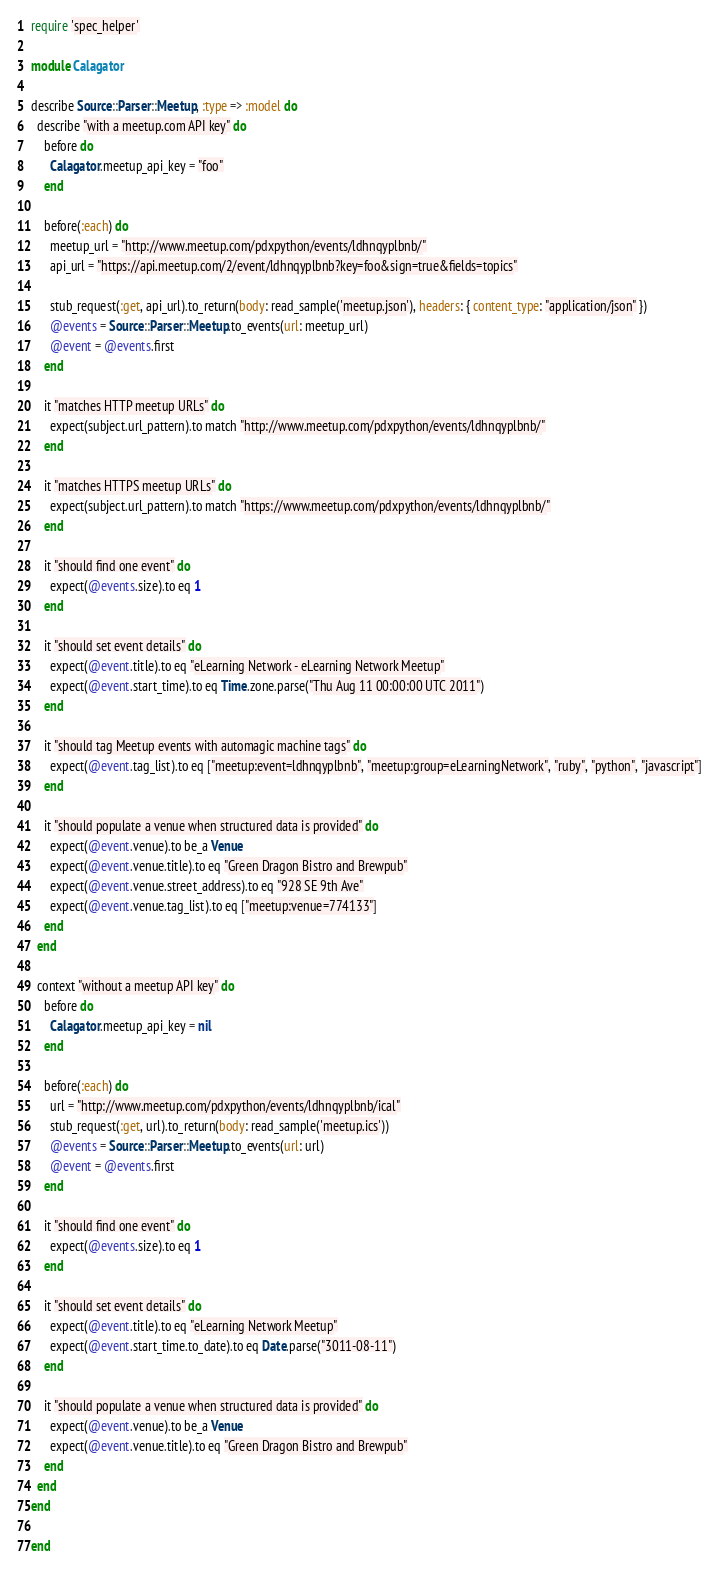<code> <loc_0><loc_0><loc_500><loc_500><_Ruby_>require 'spec_helper'

module Calagator

describe Source::Parser::Meetup, :type => :model do
  describe "with a meetup.com API key" do
    before do
      Calagator.meetup_api_key = "foo"
    end

    before(:each) do
      meetup_url = "http://www.meetup.com/pdxpython/events/ldhnqyplbnb/"
      api_url = "https://api.meetup.com/2/event/ldhnqyplbnb?key=foo&sign=true&fields=topics"

      stub_request(:get, api_url).to_return(body: read_sample('meetup.json'), headers: { content_type: "application/json" })
      @events = Source::Parser::Meetup.to_events(url: meetup_url)
      @event = @events.first
    end

    it "matches HTTP meetup URLs" do
      expect(subject.url_pattern).to match "http://www.meetup.com/pdxpython/events/ldhnqyplbnb/"
    end

    it "matches HTTPS meetup URLs" do
      expect(subject.url_pattern).to match "https://www.meetup.com/pdxpython/events/ldhnqyplbnb/"
    end

    it "should find one event" do
      expect(@events.size).to eq 1
    end

    it "should set event details" do
      expect(@event.title).to eq "eLearning Network - eLearning Network Meetup"
      expect(@event.start_time).to eq Time.zone.parse("Thu Aug 11 00:00:00 UTC 2011")
    end

    it "should tag Meetup events with automagic machine tags" do
      expect(@event.tag_list).to eq ["meetup:event=ldhnqyplbnb", "meetup:group=eLearningNetwork", "ruby", "python", "javascript"]
    end

    it "should populate a venue when structured data is provided" do
      expect(@event.venue).to be_a Venue
      expect(@event.venue.title).to eq "Green Dragon Bistro and Brewpub"
      expect(@event.venue.street_address).to eq "928 SE 9th Ave"
      expect(@event.venue.tag_list).to eq ["meetup:venue=774133"]
    end
  end

  context "without a meetup API key" do
    before do
      Calagator.meetup_api_key = nil
    end

    before(:each) do
      url = "http://www.meetup.com/pdxpython/events/ldhnqyplbnb/ical"
      stub_request(:get, url).to_return(body: read_sample('meetup.ics'))
      @events = Source::Parser::Meetup.to_events(url: url)
      @event = @events.first
    end

    it "should find one event" do
      expect(@events.size).to eq 1
    end

    it "should set event details" do
      expect(@event.title).to eq "eLearning Network Meetup"
      expect(@event.start_time.to_date).to eq Date.parse("3011-08-11")
    end

    it "should populate a venue when structured data is provided" do
      expect(@event.venue).to be_a Venue
      expect(@event.venue.title).to eq "Green Dragon Bistro and Brewpub"
    end
  end
end

end
</code> 